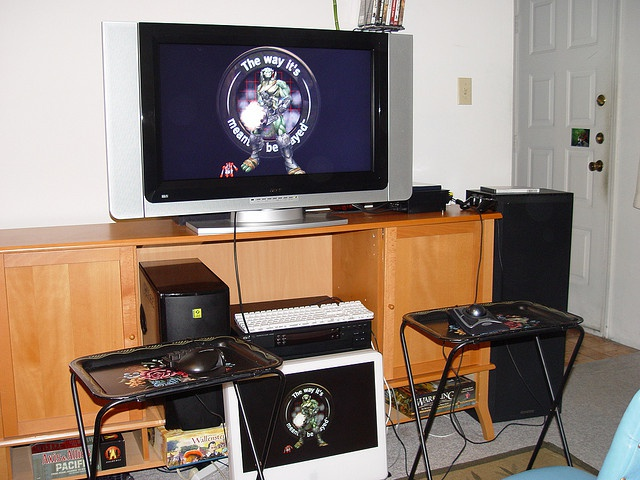Describe the objects in this image and their specific colors. I can see tv in lightgray, black, white, navy, and darkgray tones, keyboard in lightgray, darkgray, maroon, and brown tones, chair in lightgray, lightblue, and gray tones, mouse in lightgray, black, and gray tones, and mouse in lightgray, black, gray, and maroon tones in this image. 